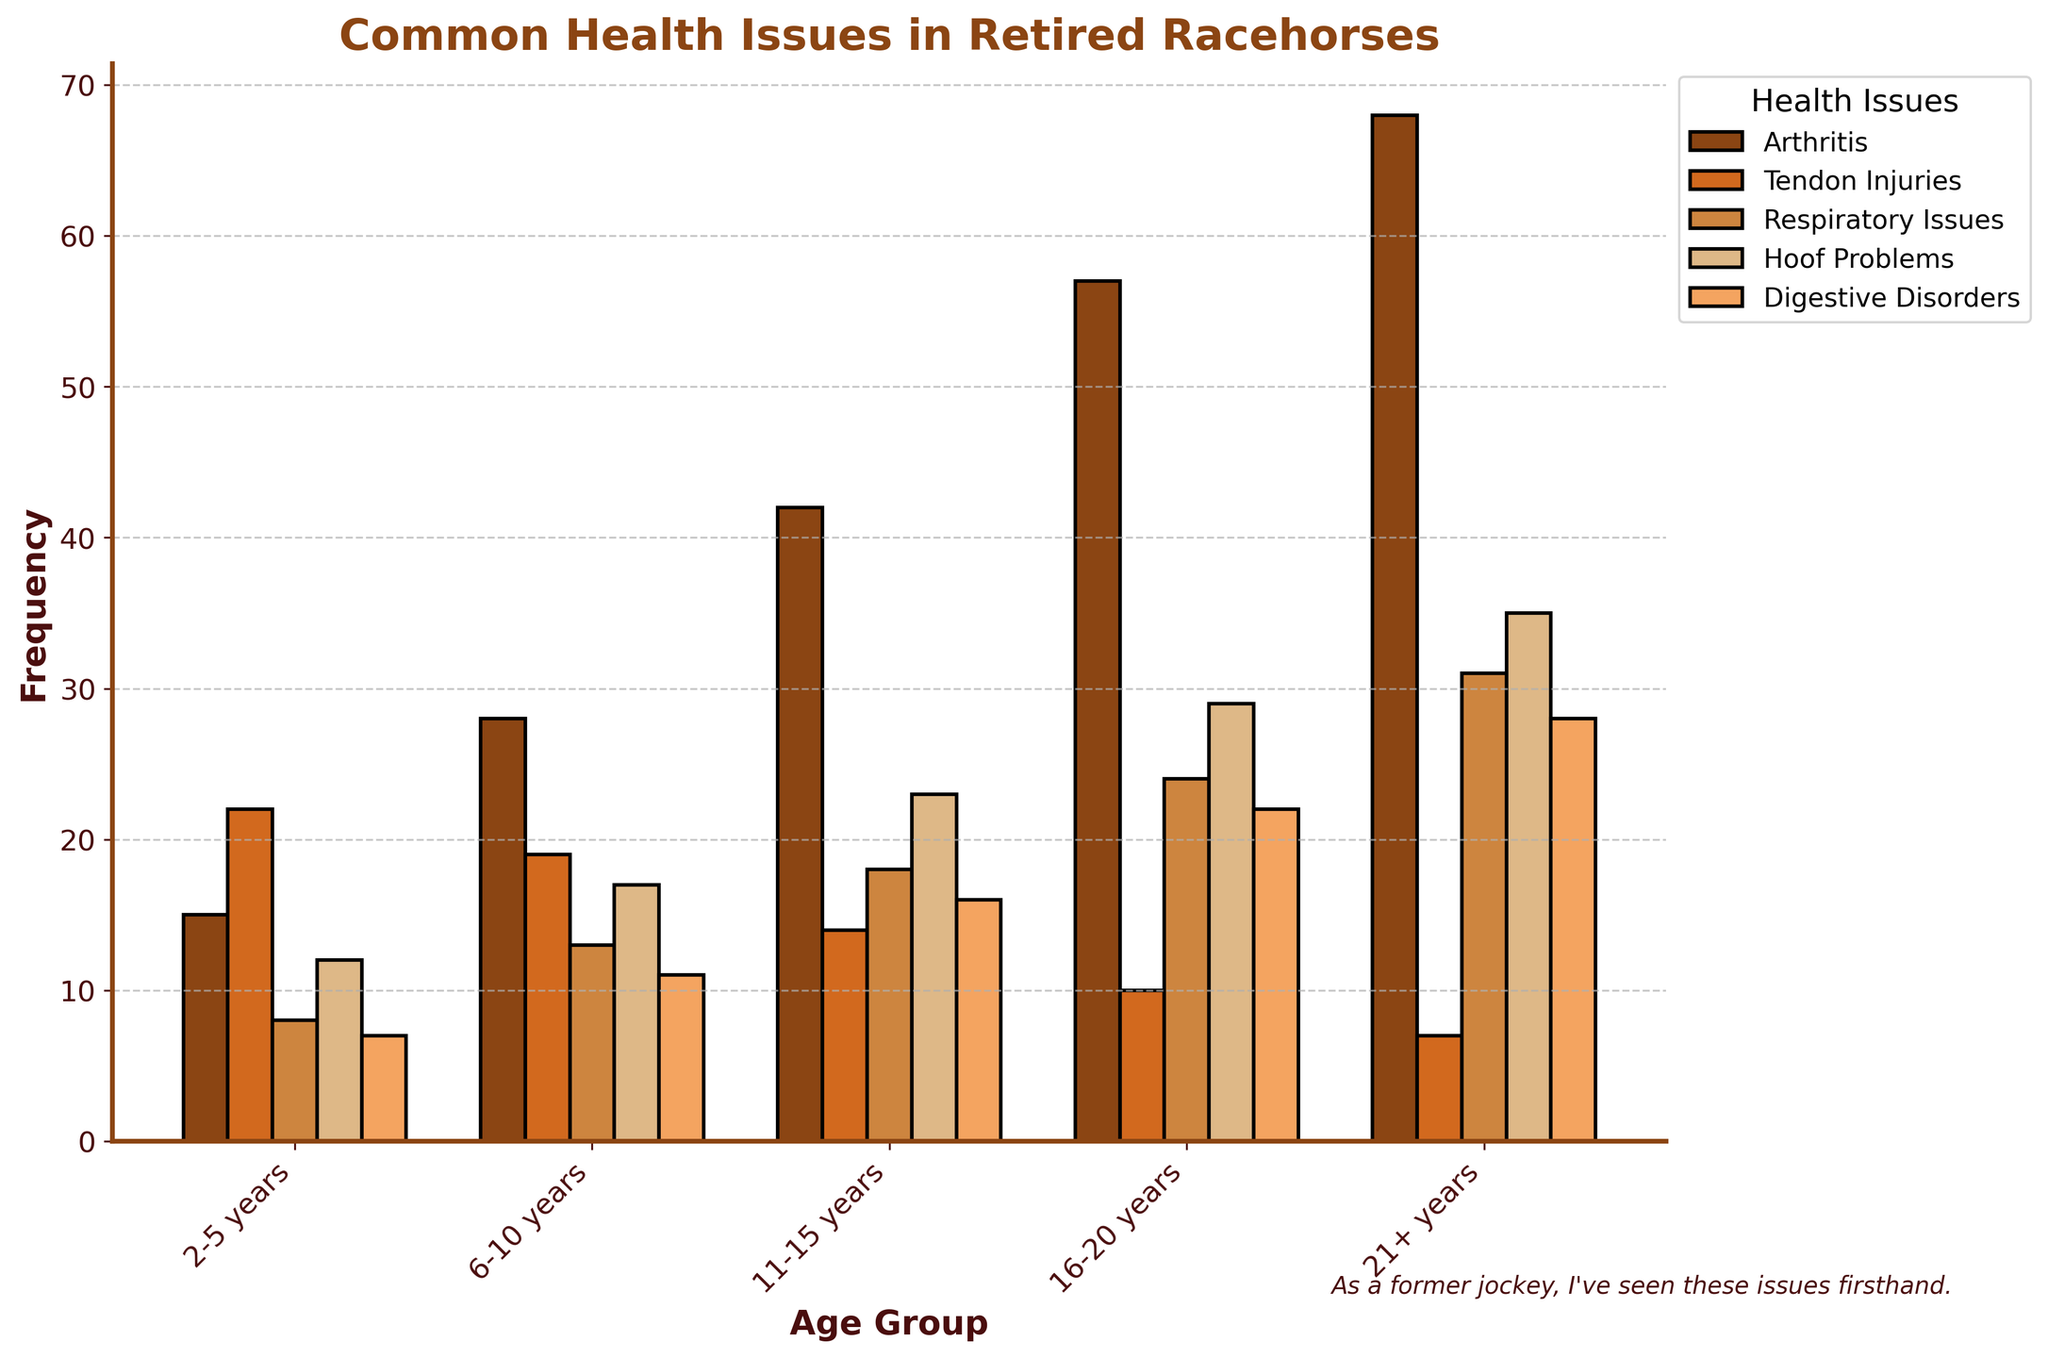Which age group has the highest frequency of arthritis? To determine the age group with the highest frequency of arthritis, examine the bar heights for the 'Arthritis' category across all age groups. The tallest bar represents the highest frequency of arthritis. The 21+ years age group has the tallest bar.
Answer: 21+ years How do respiratory issues compare between the 2-5 years and the 21+ years age groups? Look at the height of the bars for 'Respiratory Issues' in the 2-5 years and 21+ years categories. The bar for the 21+ years age group is taller, indicating a higher frequency.
Answer: Higher in 21+ years What is the combined frequency of tendon injuries and hoof problems in the 16-20 years age group? Find the frequencies for tendon injuries and hoof problems in the 16-20 years age group, which are 10 and 29, respectively. Add these values: 10 + 29 = 39.
Answer: 39 Which health issue is most common among the 6-10 years age group? Examine the heights of the bars within the 6-10 years age group for all health issues. The tallest bar corresponds to Arthritis with a frequency of 28, making it the most common issue.
Answer: Arthritis Which age group shows the least frequency of digestive disorders? Find the shortest bar in the 'Digestive Disorders' category among all age groups. The shortest bar represents the 2-5 years age group with a frequency of 7.
Answer: 2-5 years What is the total frequency of all health issues in the 11-15 years age group? Sum the frequencies of all health issues in the 11-15 years age group: 42 (Arthritis) + 14 (Tendon Injuries) + 18 (Respiratory Issues) + 23 (Hoof Problems) + 16 (Digestive Disorders). The total is 113.
Answer: 113 By how much does the frequency of arthritis in the 16-20 age group exceed that in the 6-10 age group? Subtract the frequency of arthritis in the 6-10 years age group from that in the 16-20 years age group: 57 - 28. The difference is 29.
Answer: 29 Compare the frequency of digestive disorders between the 11-15 and 21+ years age groups. Is there an increase or decrease, and by how much? Subtract the frequency of digestive disorders in the 11-15 age group from that in the 21+ age group: 28 - 16. The result is an increase of 12.
Answer: Increase by 12 What is the average frequency of hoof problems across all age groups? Find the sum of frequencies for hoof problems and divide by the number of age groups: (12 + 17 + 23 + 29 + 35) / 5. The average is 23.2.
Answer: 23.2 